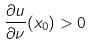<formula> <loc_0><loc_0><loc_500><loc_500>\frac { \partial u } { \partial \nu } ( x _ { 0 } ) > 0</formula> 